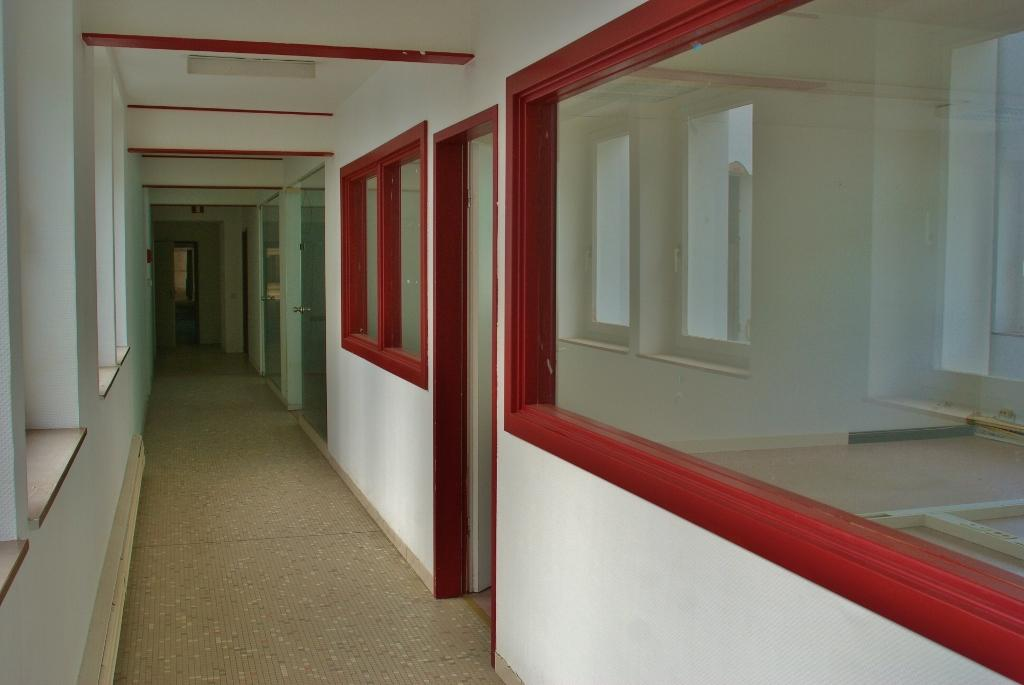What type of location is depicted in the image? The image shows an inside view of a building. What can be seen in the middle of the image? There is a corridor in the middle of the image. What is visible on the sides of the corridor? There is a wall visible in the image. What can be seen on the right side of the image? There are windows on the right side of the image. What type of legs can be seen supporting the building in the image? There are no legs visible in the image; it shows an inside view of a building with a corridor, wall, and windows. 